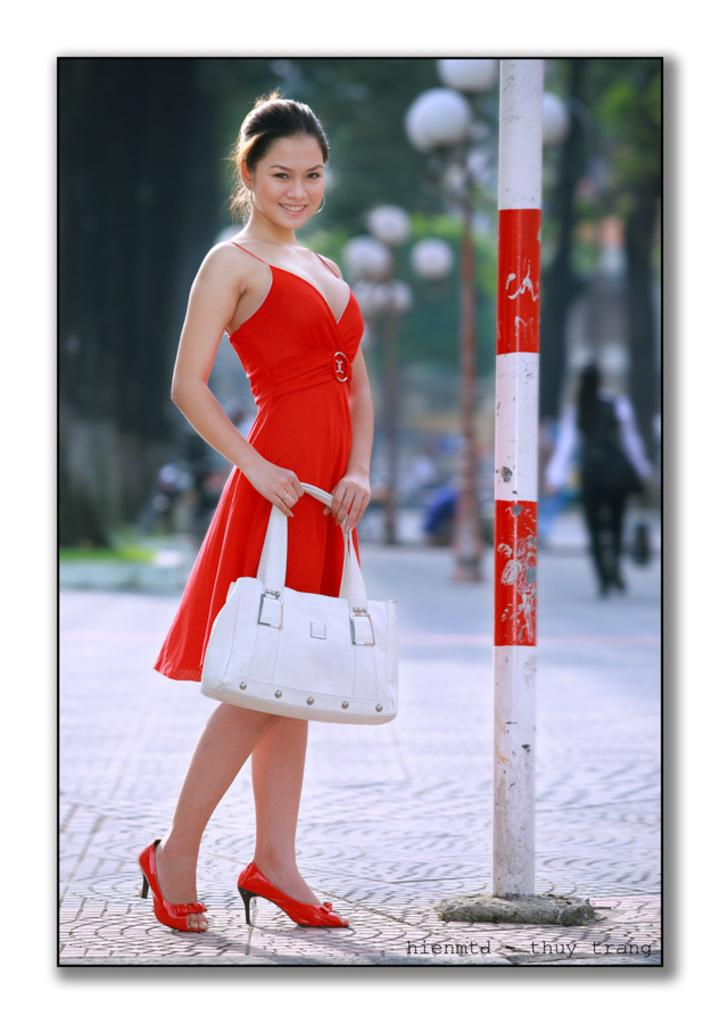Who is the main subject in the image? There is a lady in the image. What is the lady wearing? The lady is wearing a red dress. What is the lady holding in the image? The lady is holding a white handbag. What can be seen in the background of the image? There are street light poles and a person in the background of the image. What finger does the lady regret cutting in the image? There is no mention of a finger or any regret in the image. 